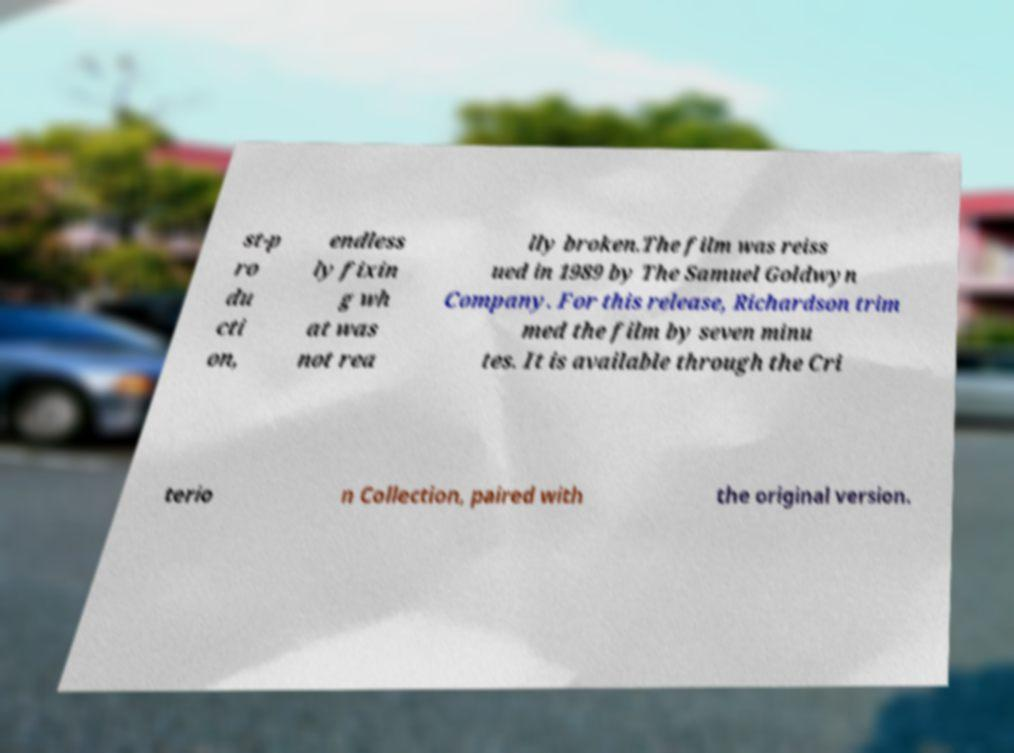Please read and relay the text visible in this image. What does it say? st-p ro du cti on, endless ly fixin g wh at was not rea lly broken.The film was reiss ued in 1989 by The Samuel Goldwyn Company. For this release, Richardson trim med the film by seven minu tes. It is available through the Cri terio n Collection, paired with the original version. 